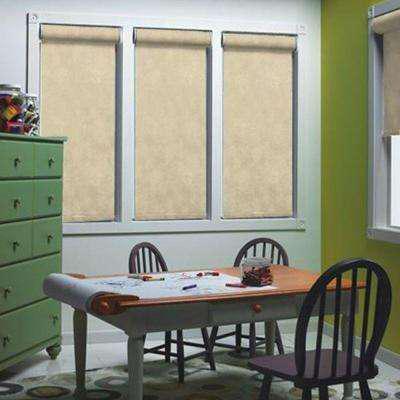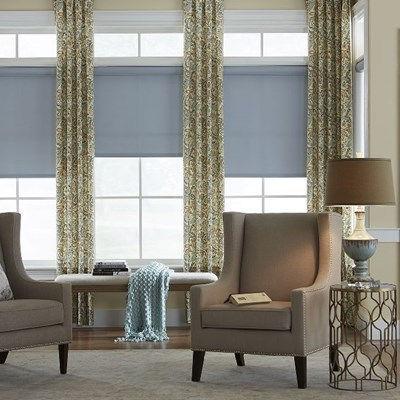The first image is the image on the left, the second image is the image on the right. For the images displayed, is the sentence "At least one window shade is completely closed." factually correct? Answer yes or no. Yes. The first image is the image on the left, the second image is the image on the right. Examine the images to the left and right. Is the description "There are three windows in a row that are on the same wall." accurate? Answer yes or no. Yes. 